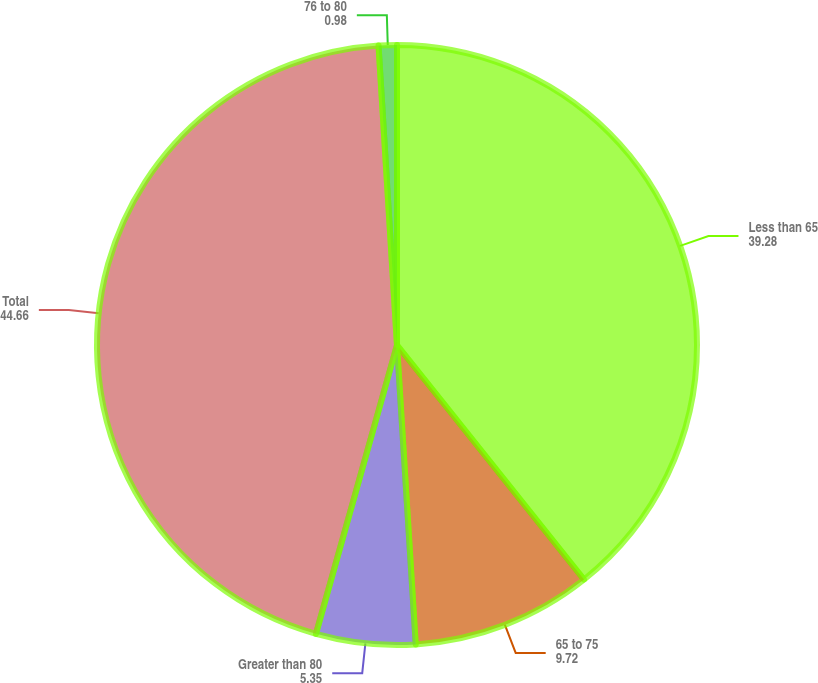Convert chart to OTSL. <chart><loc_0><loc_0><loc_500><loc_500><pie_chart><fcel>Less than 65<fcel>65 to 75<fcel>Greater than 80<fcel>Total<fcel>76 to 80<nl><fcel>39.28%<fcel>9.72%<fcel>5.35%<fcel>44.66%<fcel>0.98%<nl></chart> 